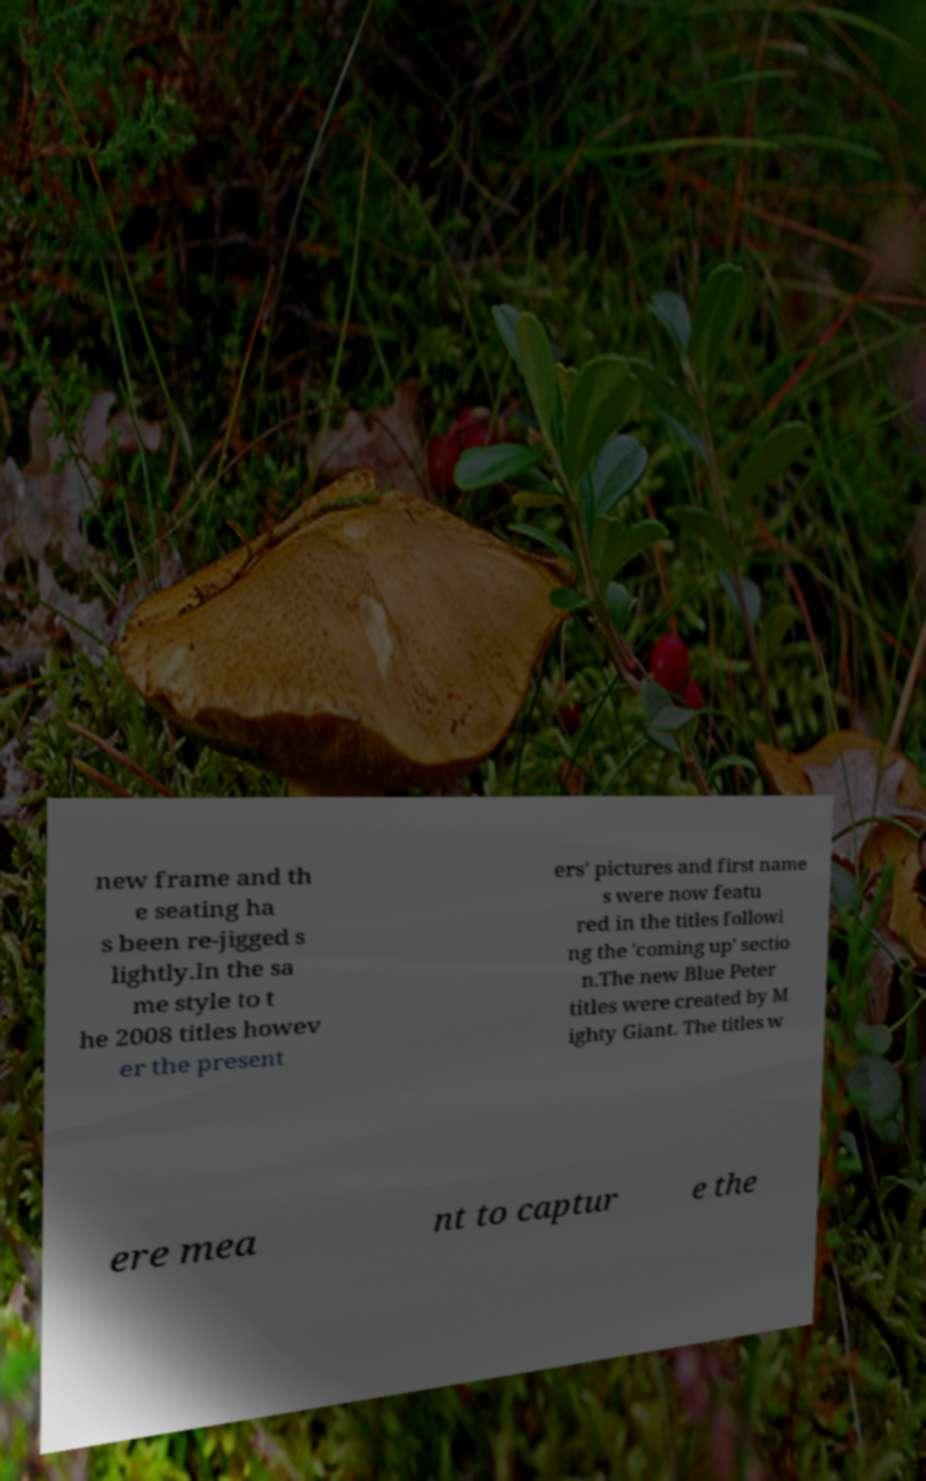Please identify and transcribe the text found in this image. new frame and th e seating ha s been re-jigged s lightly.In the sa me style to t he 2008 titles howev er the present ers' pictures and first name s were now featu red in the titles followi ng the 'coming up' sectio n.The new Blue Peter titles were created by M ighty Giant. The titles w ere mea nt to captur e the 